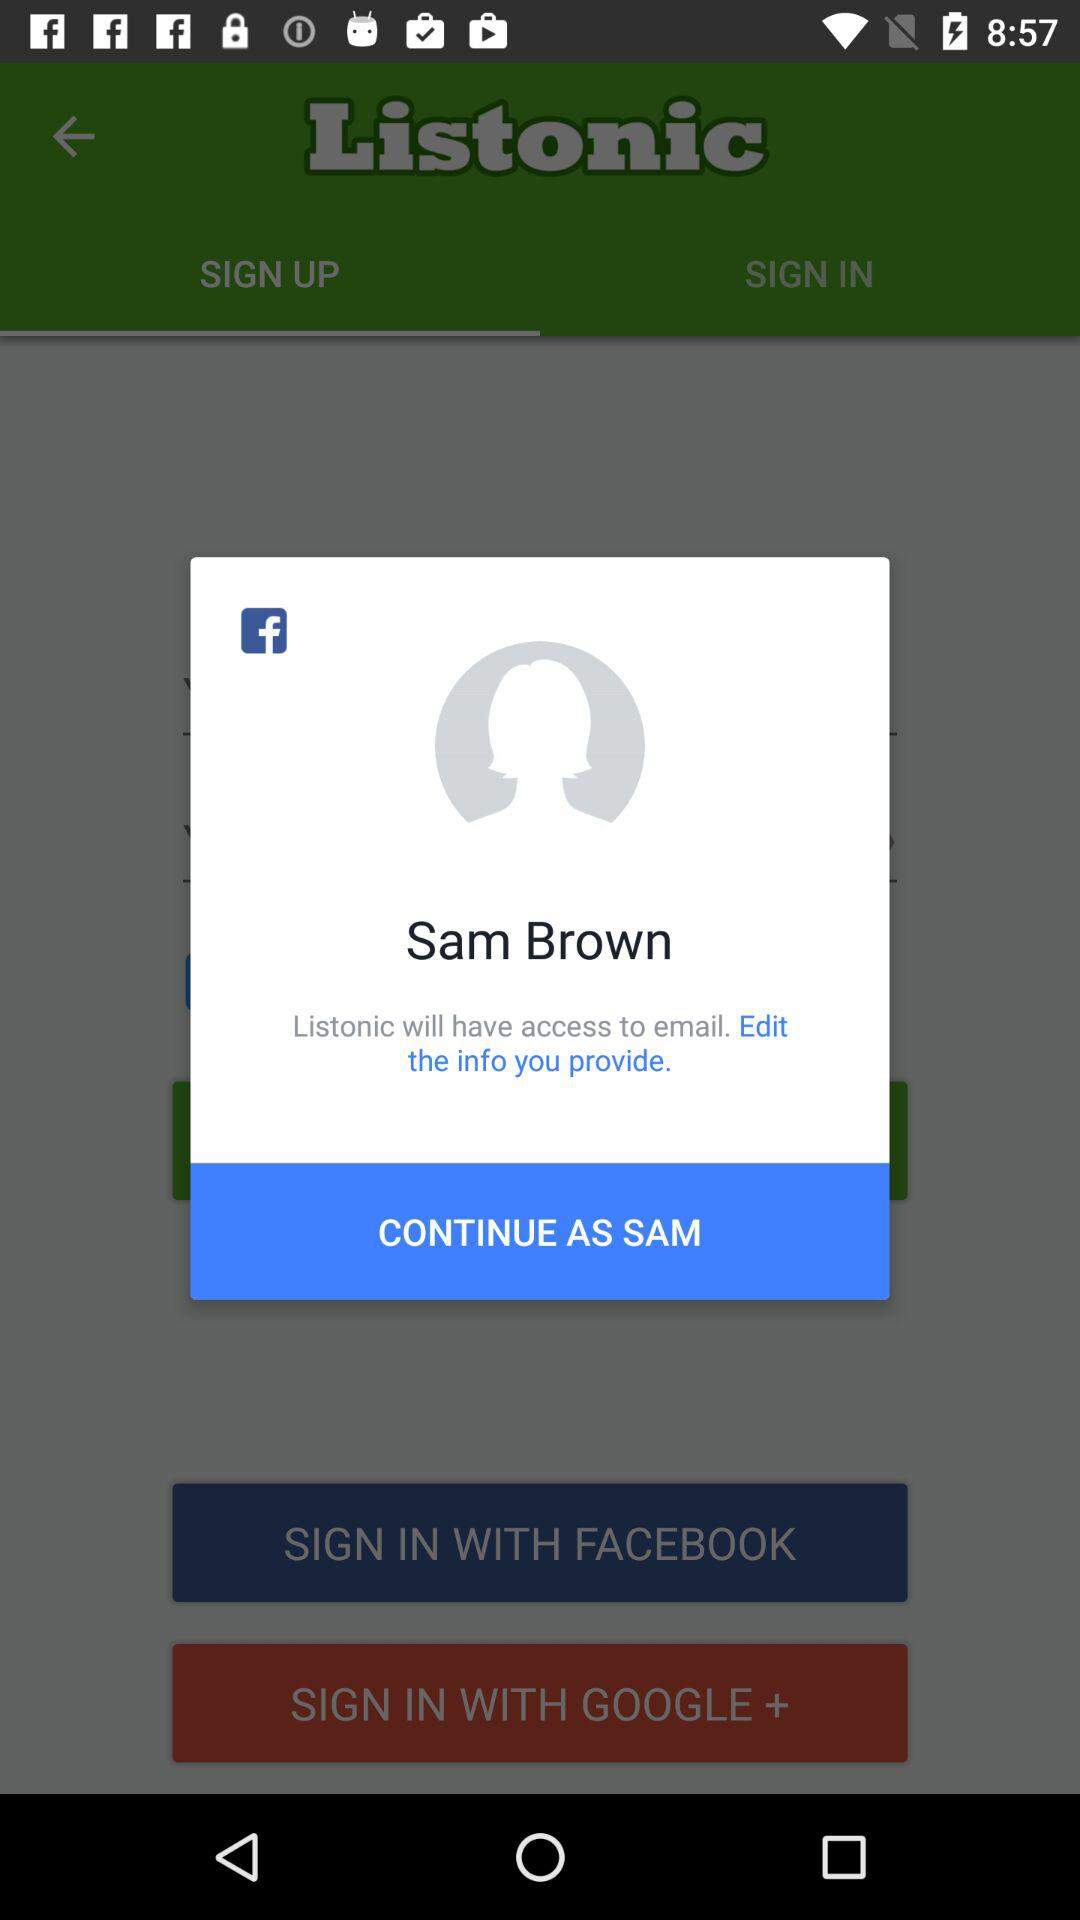What is the login name? The login name is Sam Brown. 